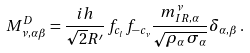Convert formula to latex. <formula><loc_0><loc_0><loc_500><loc_500>M _ { \nu , \alpha \beta } ^ { D } = \frac { i h } { \sqrt { 2 } R ^ { \prime } } \, f _ { c _ { l } } f _ { - c _ { \nu } } \frac { m _ { I R , \alpha } ^ { \nu } } { \sqrt { \rho _ { \alpha } \, \sigma _ { \alpha } } } \delta _ { \alpha , \beta } \, .</formula> 